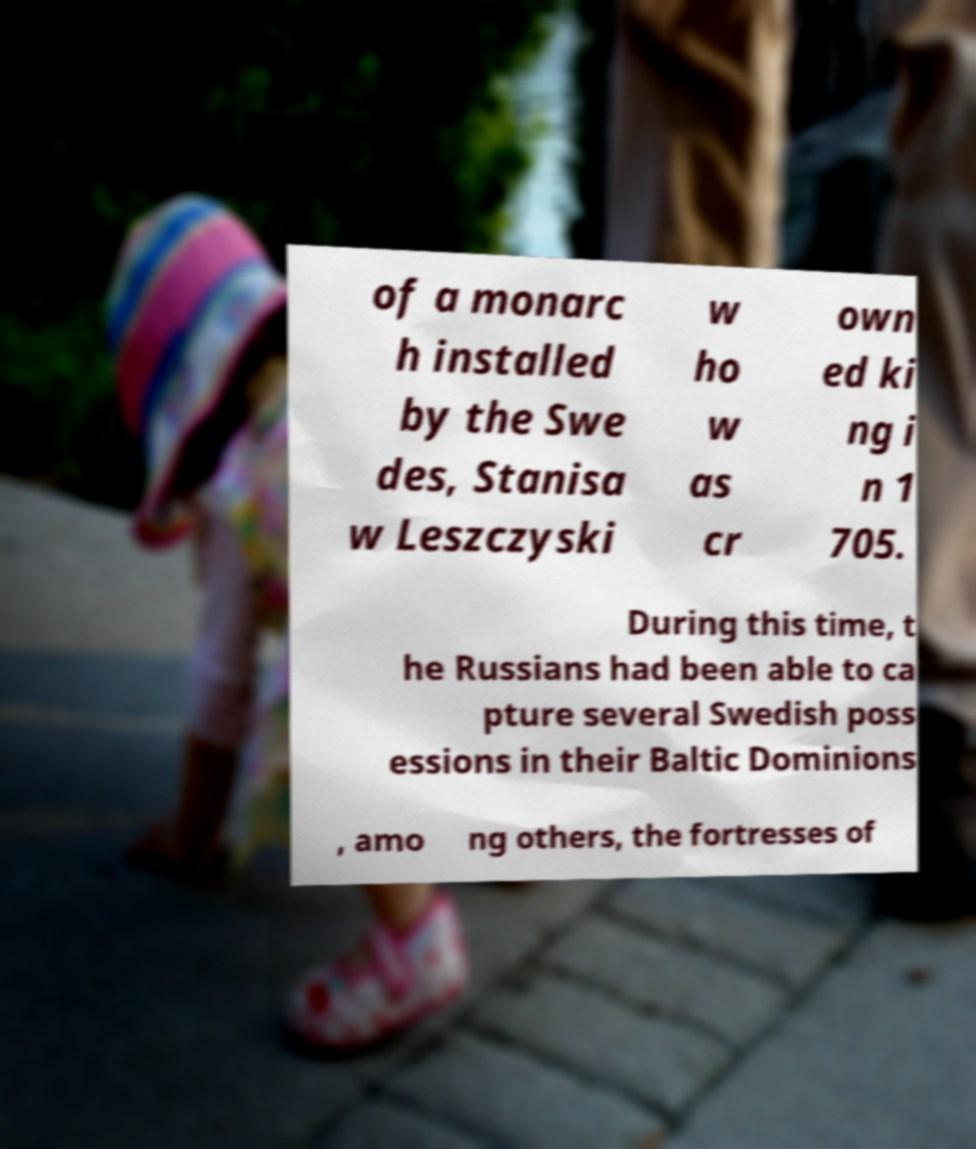There's text embedded in this image that I need extracted. Can you transcribe it verbatim? of a monarc h installed by the Swe des, Stanisa w Leszczyski w ho w as cr own ed ki ng i n 1 705. During this time, t he Russians had been able to ca pture several Swedish poss essions in their Baltic Dominions , amo ng others, the fortresses of 